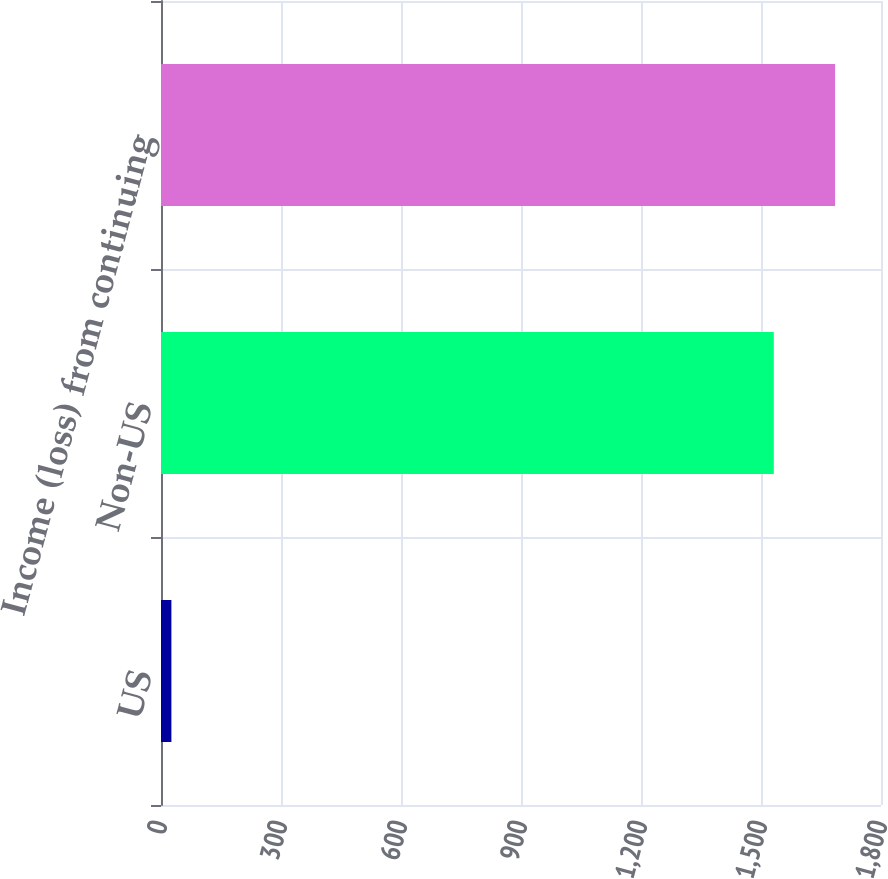<chart> <loc_0><loc_0><loc_500><loc_500><bar_chart><fcel>US<fcel>Non-US<fcel>Income (loss) from continuing<nl><fcel>26<fcel>1532<fcel>1685.2<nl></chart> 